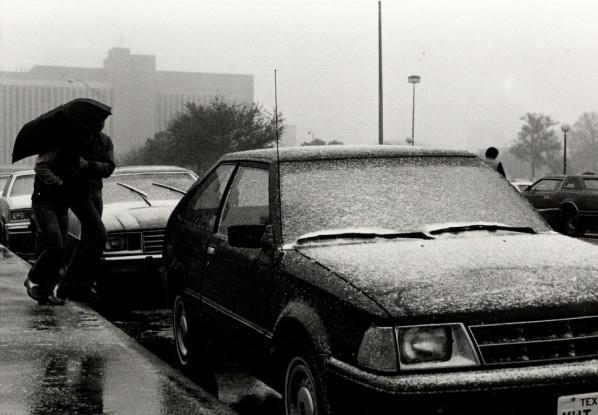How many cars are in the photo?
Give a very brief answer. 4. 